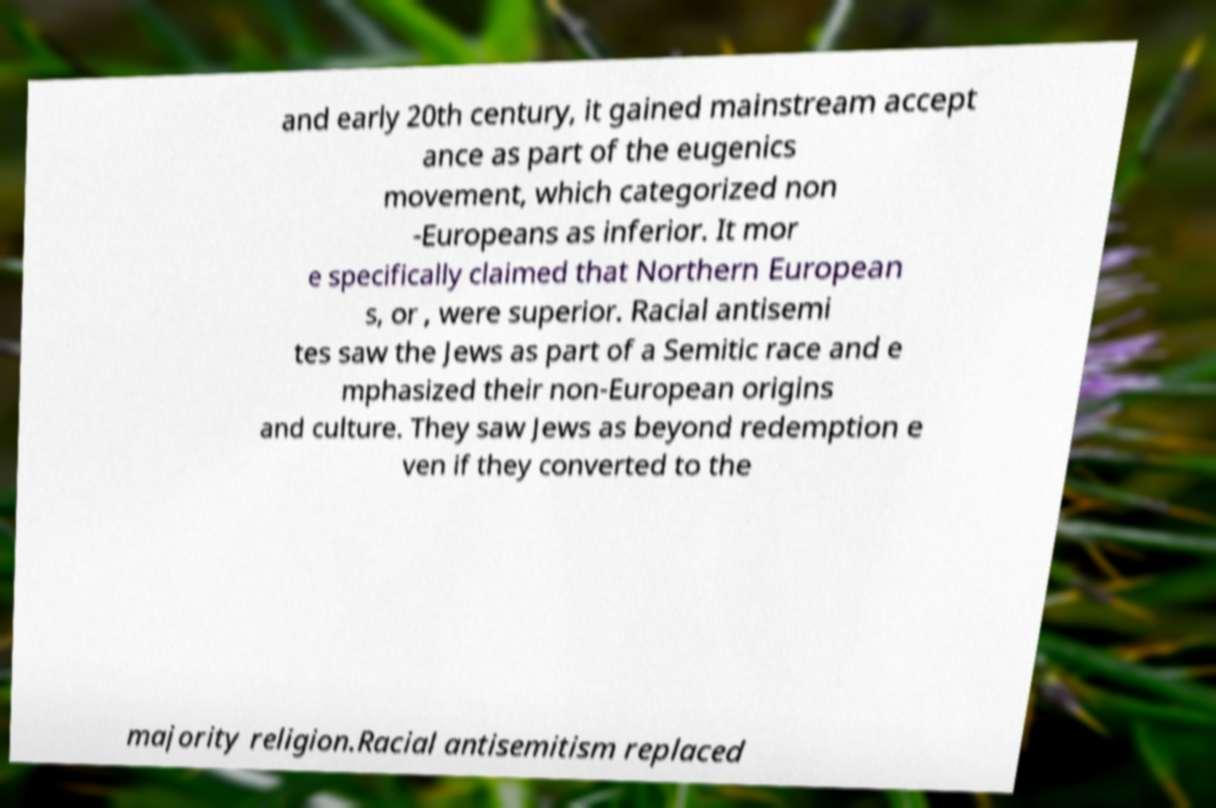Please read and relay the text visible in this image. What does it say? and early 20th century, it gained mainstream accept ance as part of the eugenics movement, which categorized non -Europeans as inferior. It mor e specifically claimed that Northern European s, or , were superior. Racial antisemi tes saw the Jews as part of a Semitic race and e mphasized their non-European origins and culture. They saw Jews as beyond redemption e ven if they converted to the majority religion.Racial antisemitism replaced 